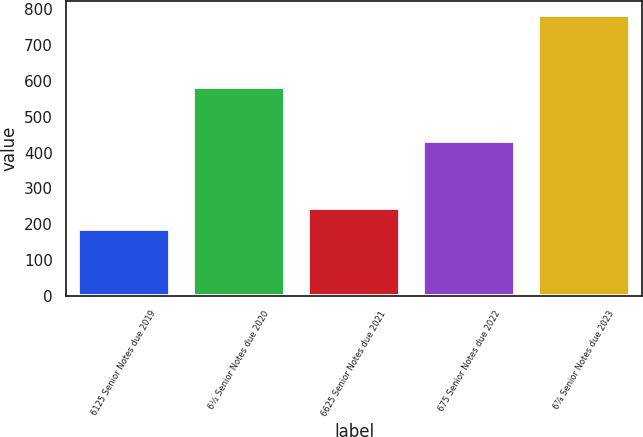Convert chart to OTSL. <chart><loc_0><loc_0><loc_500><loc_500><bar_chart><fcel>6125 Senior Notes due 2019<fcel>6½ Senior Notes due 2020<fcel>6625 Senior Notes due 2021<fcel>675 Senior Notes due 2022<fcel>6⅞ Senior Notes due 2023<nl><fcel>186<fcel>583<fcel>245.9<fcel>432<fcel>785<nl></chart> 